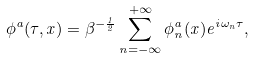<formula> <loc_0><loc_0><loc_500><loc_500>\phi ^ { a } ( \tau , x ) = \beta ^ { - \frac { 1 } { 2 } } \sum _ { n = - \infty } ^ { + \infty } \phi _ { n } ^ { a } ( x ) e ^ { i \omega _ { n } \tau } ,</formula> 